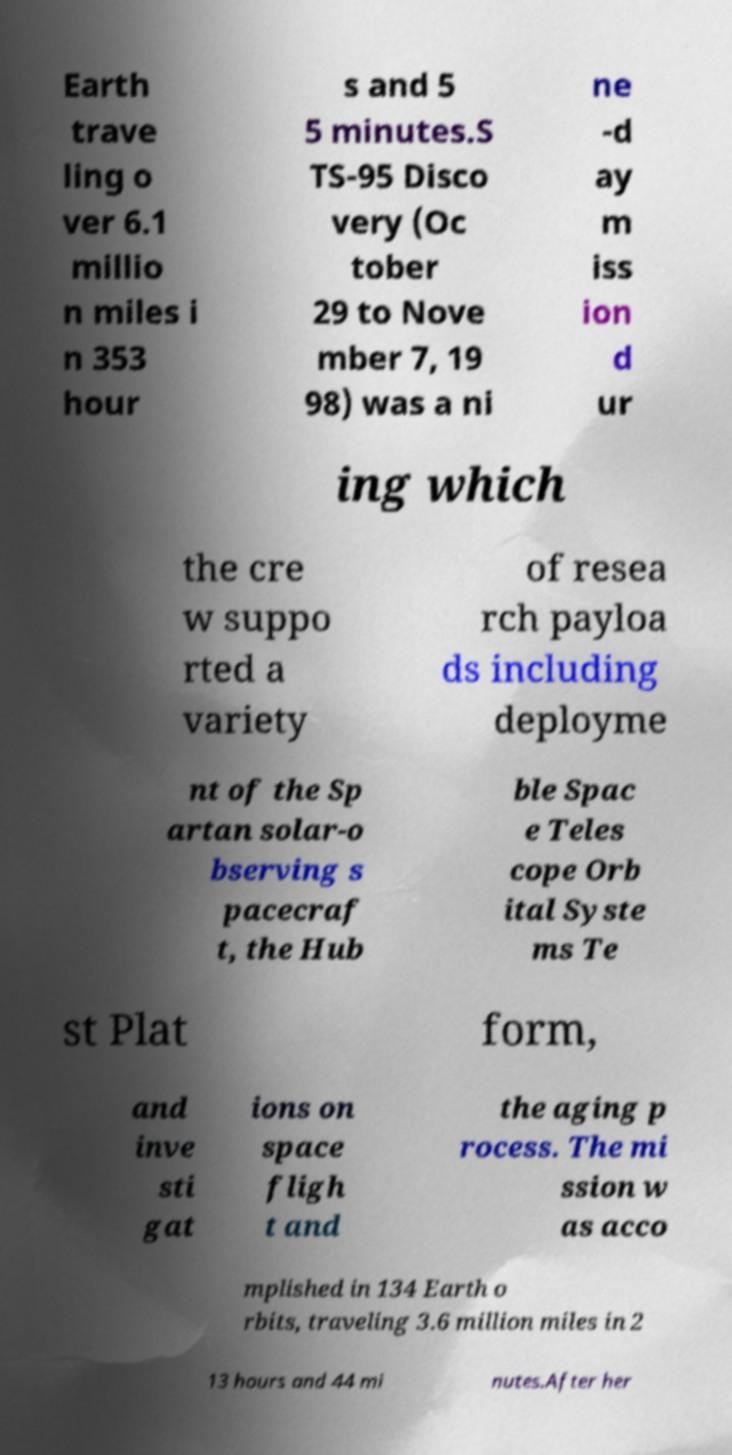Can you accurately transcribe the text from the provided image for me? Earth trave ling o ver 6.1 millio n miles i n 353 hour s and 5 5 minutes.S TS-95 Disco very (Oc tober 29 to Nove mber 7, 19 98) was a ni ne -d ay m iss ion d ur ing which the cre w suppo rted a variety of resea rch payloa ds including deployme nt of the Sp artan solar-o bserving s pacecraf t, the Hub ble Spac e Teles cope Orb ital Syste ms Te st Plat form, and inve sti gat ions on space fligh t and the aging p rocess. The mi ssion w as acco mplished in 134 Earth o rbits, traveling 3.6 million miles in 2 13 hours and 44 mi nutes.After her 